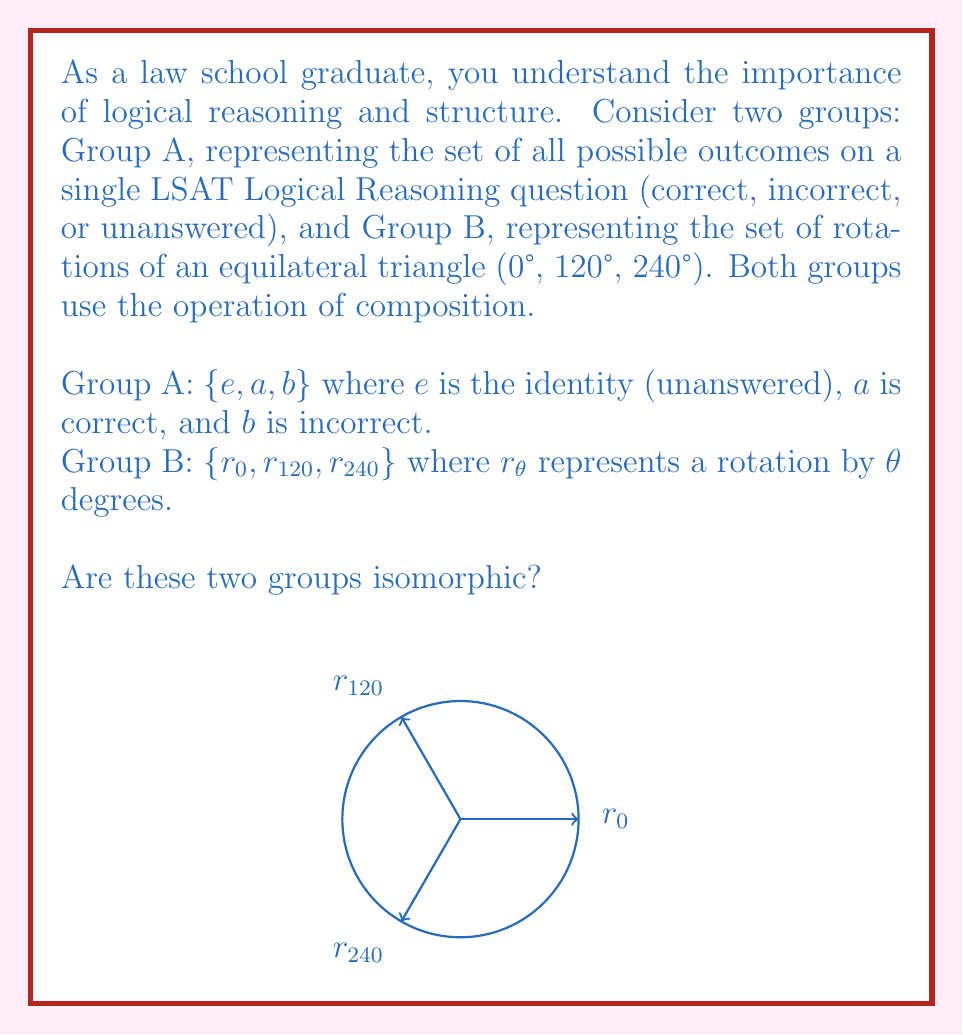Give your solution to this math problem. To determine if two groups are isomorphic, we need to check if there exists a bijective homomorphism between them. Let's approach this step-by-step:

1) First, we note that both groups have the same order (number of elements), which is a necessary condition for isomorphism.

2) Next, we need to check if the groups have the same structure. Let's construct their Cayley tables:

   Group A:
   $$ \begin{array}{c|ccc}
      \circ & e & a & b \\
      \hline
      e & e & a & b \\
      a & a & b & e \\
      b & b & e & a
   \end{array} $$

   Group B:
   $$ \begin{array}{c|ccc}
      \circ & r_0 & r_{120} & r_{240} \\
      \hline
      r_0 & r_0 & r_{120} & r_{240} \\
      r_{120} & r_{120} & r_{240} & r_0 \\
      r_{240} & r_{240} & r_0 & r_{120}
   \end{array} $$

3) We can see that these tables have the same structure. This suggests that an isomorphism might exist.

4) To confirm, let's define a mapping $\phi: A \to B$ as follows:
   $\phi(e) = r_0$
   $\phi(a) = r_{120}$
   $\phi(b) = r_{240}$

5) We need to verify that this mapping preserves the group operation:
   $\phi(a \circ a) = \phi(b) = r_{240} = r_{120} \circ r_{120} = \phi(a) \circ \phi(a)$
   $\phi(a \circ b) = \phi(e) = r_0 = r_{120} \circ r_{240} = \phi(a) \circ \phi(b)$
   (Similarly for other combinations)

6) The mapping is bijective as it's a one-to-one correspondence between elements of A and B.

Therefore, we have found an isomorphism between Group A and Group B, proving that they are indeed isomorphic.
Answer: Yes, the groups are isomorphic. 